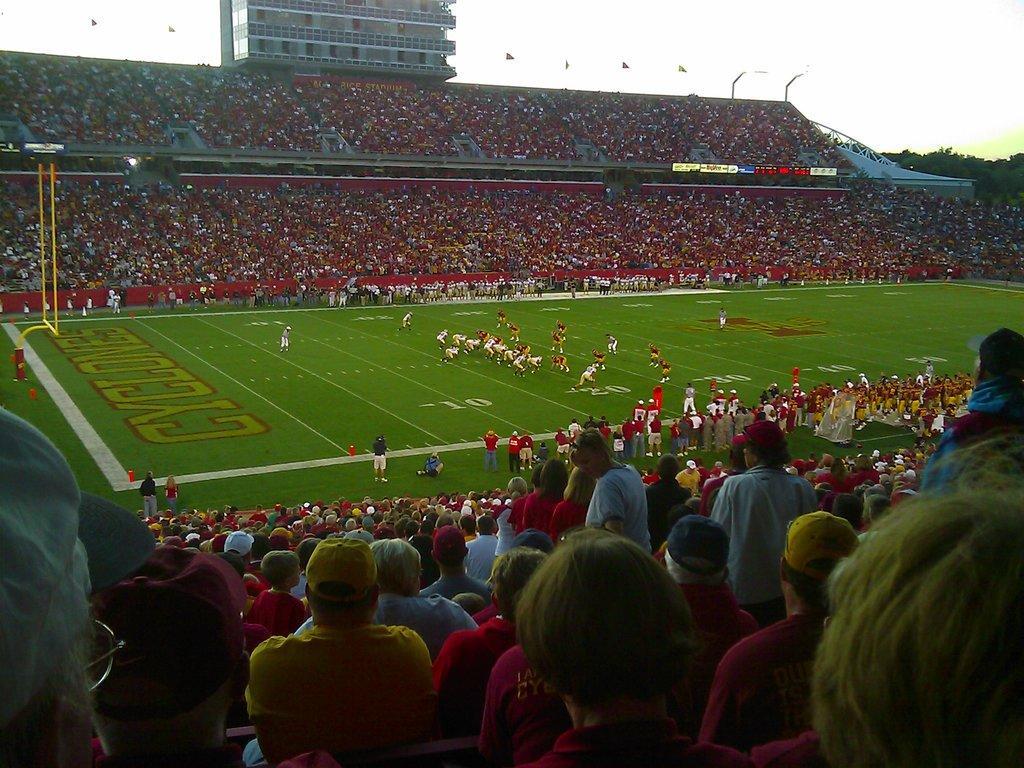How would you summarize this image in a sentence or two? In the picture I can see few persons standing on a greenery ground and there are few audience on either sides of them and there is a building,few flags and trees in the background. 